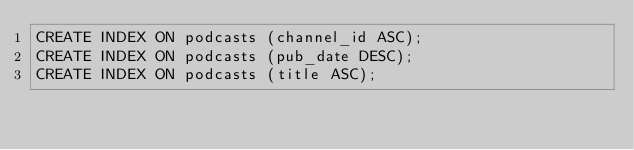Convert code to text. <code><loc_0><loc_0><loc_500><loc_500><_SQL_>CREATE INDEX ON podcasts (channel_id ASC);
CREATE INDEX ON podcasts (pub_date DESC);
CREATE INDEX ON podcasts (title ASC);
</code> 